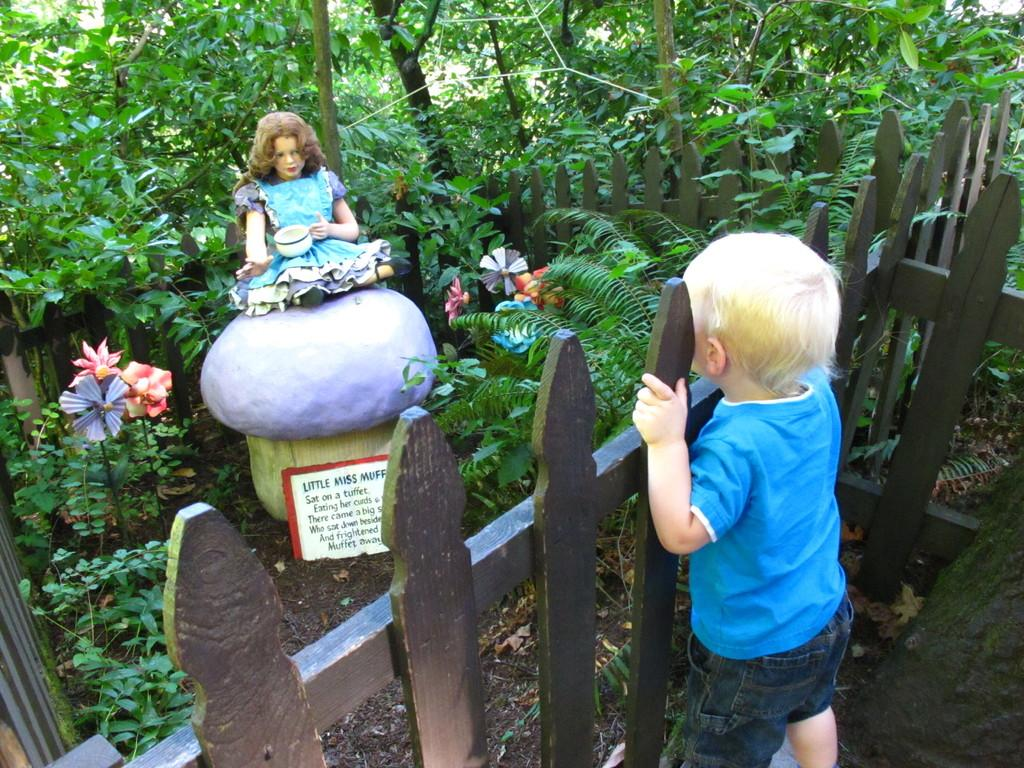Who is the main subject in the image? There is a boy visible in the image. Where is the boy located in relation to other objects in the image? The boy is in front of a fence. What type of environment can be seen in the image? There is a garden in the image. What is a notable feature of the garden? There is a statue of a girl in the garden. What type of plants are present in the garden? Flowers are present in the garden. What type of liquid is being poured over the boy in the image? There is no liquid being poured over the boy in the image. 